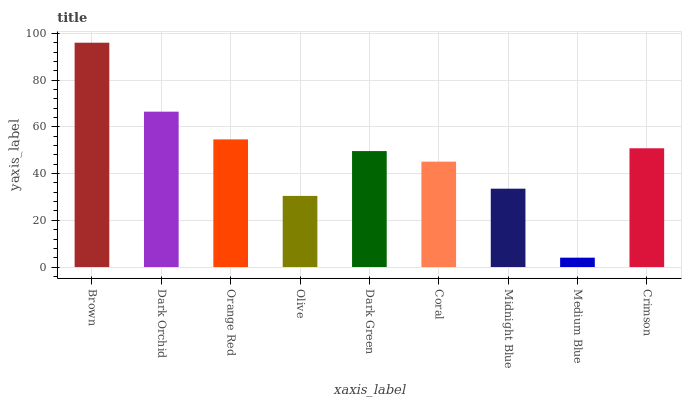Is Dark Orchid the minimum?
Answer yes or no. No. Is Dark Orchid the maximum?
Answer yes or no. No. Is Brown greater than Dark Orchid?
Answer yes or no. Yes. Is Dark Orchid less than Brown?
Answer yes or no. Yes. Is Dark Orchid greater than Brown?
Answer yes or no. No. Is Brown less than Dark Orchid?
Answer yes or no. No. Is Dark Green the high median?
Answer yes or no. Yes. Is Dark Green the low median?
Answer yes or no. Yes. Is Olive the high median?
Answer yes or no. No. Is Olive the low median?
Answer yes or no. No. 